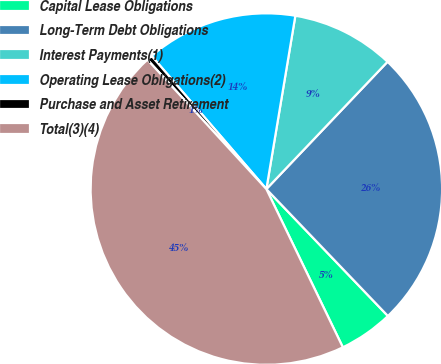<chart> <loc_0><loc_0><loc_500><loc_500><pie_chart><fcel>Capital Lease Obligations<fcel>Long-Term Debt Obligations<fcel>Interest Payments(1)<fcel>Operating Lease Obligations(2)<fcel>Purchase and Asset Retirement<fcel>Total(3)(4)<nl><fcel>4.99%<fcel>25.74%<fcel>9.47%<fcel>13.96%<fcel>0.51%<fcel>45.34%<nl></chart> 